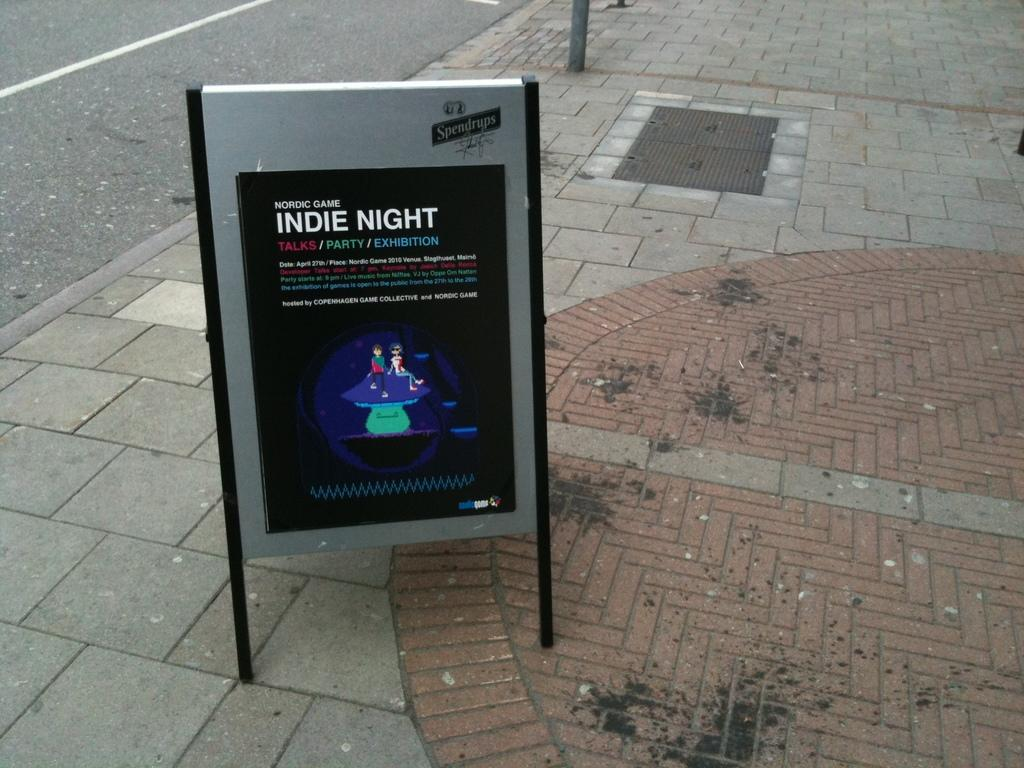Provide a one-sentence caption for the provided image. The Nordic Game Indie Night features Talks, Party, and Exhibition. 